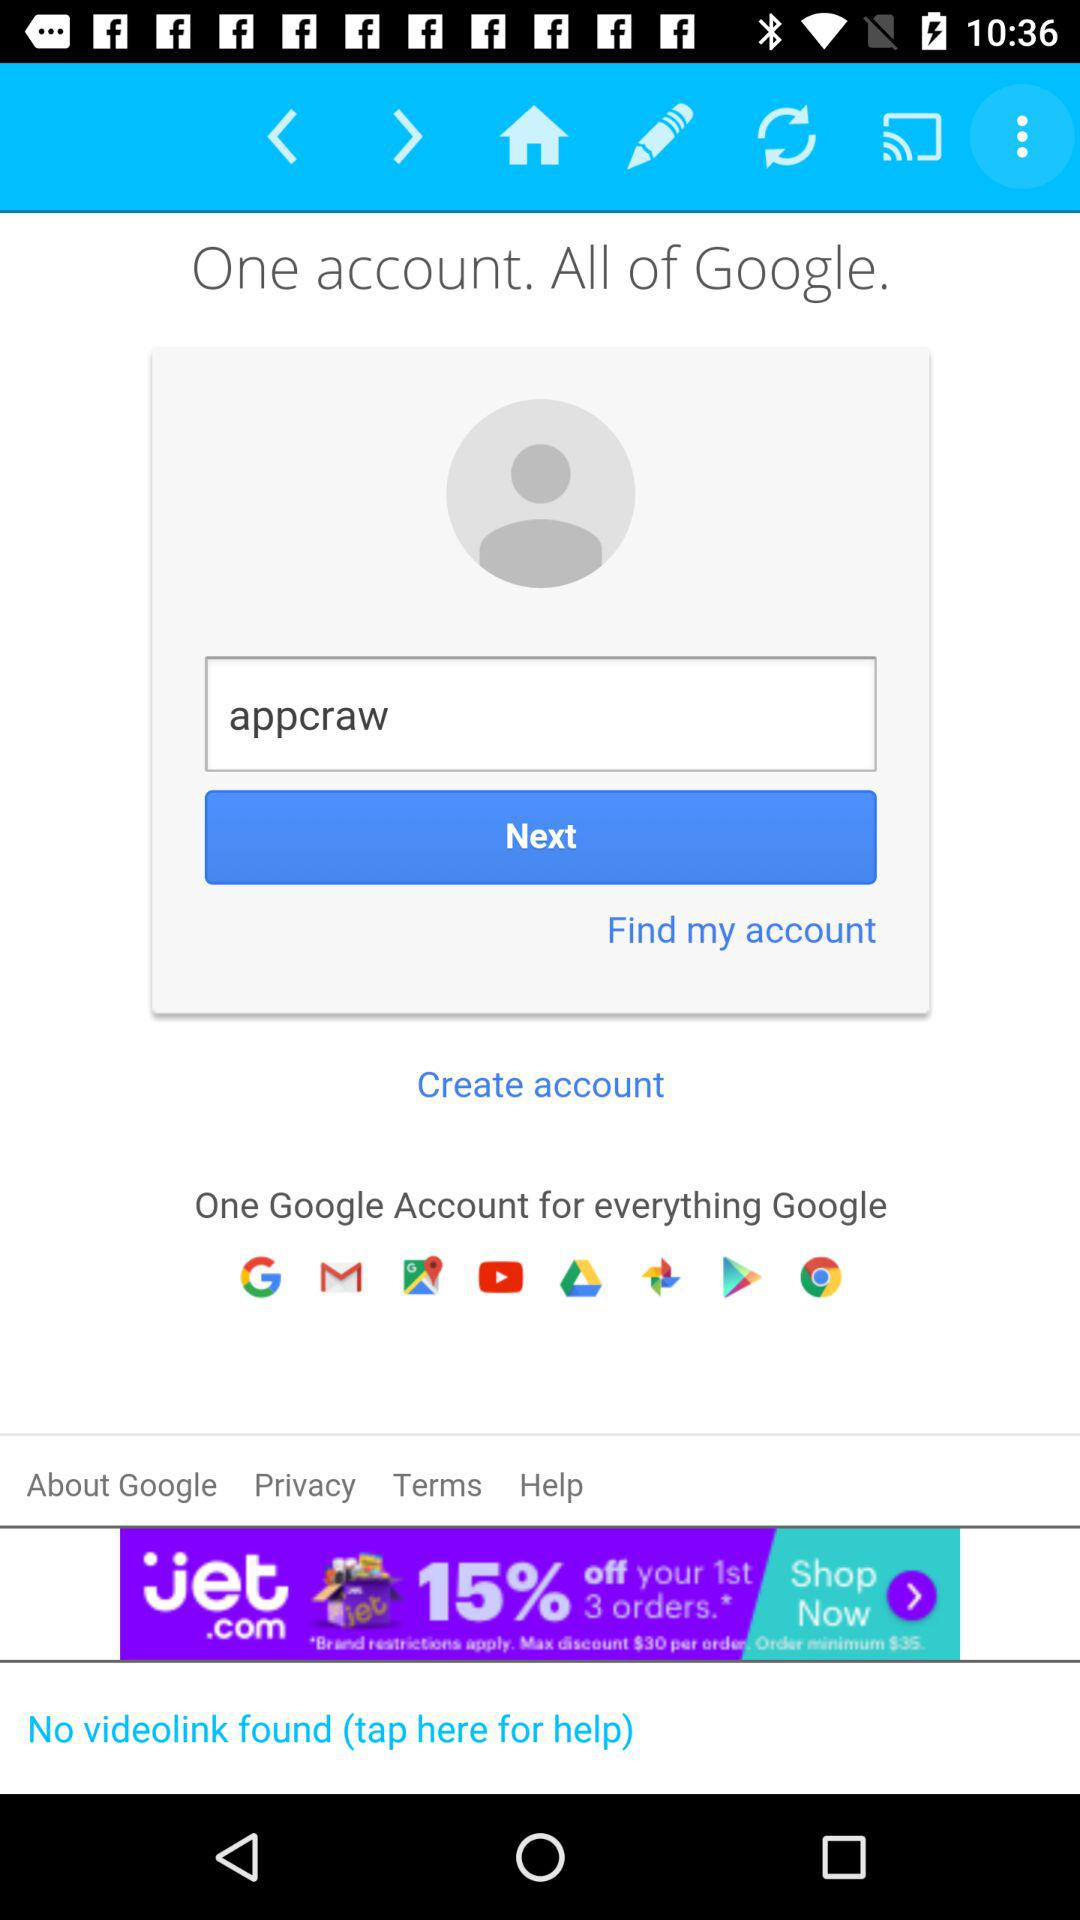What is the username? The username is "appcraw". 